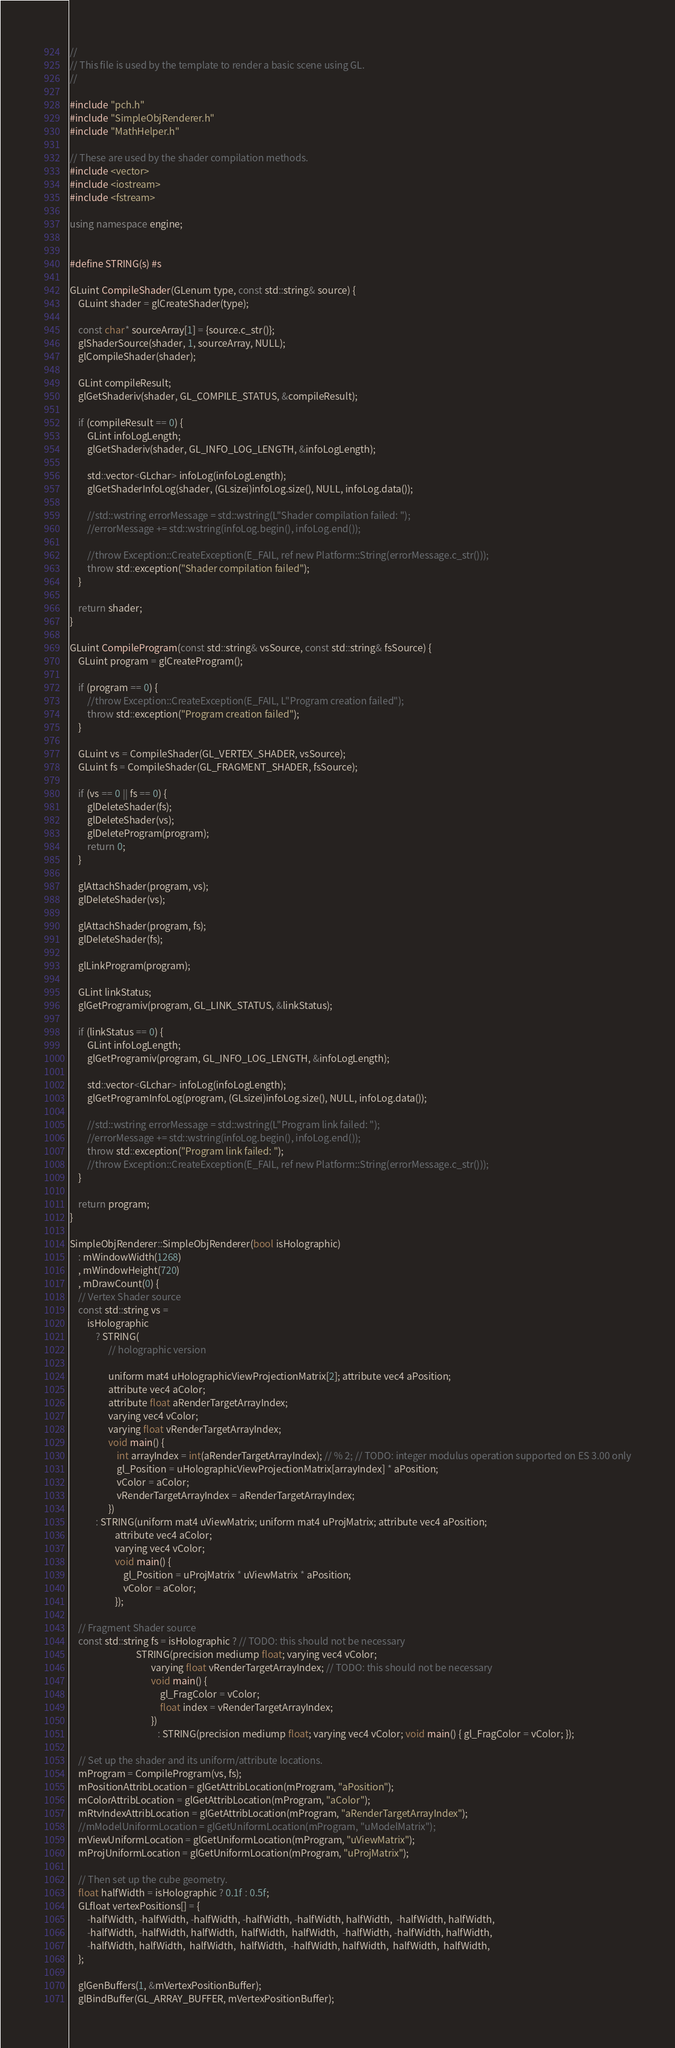<code> <loc_0><loc_0><loc_500><loc_500><_C++_>//
// This file is used by the template to render a basic scene using GL.
//

#include "pch.h"
#include "SimpleObjRenderer.h"
#include "MathHelper.h"

// These are used by the shader compilation methods.
#include <vector>
#include <iostream>
#include <fstream>

using namespace engine;


#define STRING(s) #s

GLuint CompileShader(GLenum type, const std::string& source) {
    GLuint shader = glCreateShader(type);

    const char* sourceArray[1] = {source.c_str()};
    glShaderSource(shader, 1, sourceArray, NULL);
    glCompileShader(shader);

    GLint compileResult;
    glGetShaderiv(shader, GL_COMPILE_STATUS, &compileResult);

    if (compileResult == 0) {
        GLint infoLogLength;
        glGetShaderiv(shader, GL_INFO_LOG_LENGTH, &infoLogLength);

        std::vector<GLchar> infoLog(infoLogLength);
        glGetShaderInfoLog(shader, (GLsizei)infoLog.size(), NULL, infoLog.data());

        //std::wstring errorMessage = std::wstring(L"Shader compilation failed: ");
        //errorMessage += std::wstring(infoLog.begin(), infoLog.end());

        //throw Exception::CreateException(E_FAIL, ref new Platform::String(errorMessage.c_str()));
        throw std::exception("Shader compilation failed");
    }

    return shader;
}

GLuint CompileProgram(const std::string& vsSource, const std::string& fsSource) {
    GLuint program = glCreateProgram();

    if (program == 0) {
        //throw Exception::CreateException(E_FAIL, L"Program creation failed");
        throw std::exception("Program creation failed");
    }

    GLuint vs = CompileShader(GL_VERTEX_SHADER, vsSource);
    GLuint fs = CompileShader(GL_FRAGMENT_SHADER, fsSource);

    if (vs == 0 || fs == 0) {
        glDeleteShader(fs);
        glDeleteShader(vs);
        glDeleteProgram(program);
        return 0;
    }

    glAttachShader(program, vs);
    glDeleteShader(vs);

    glAttachShader(program, fs);
    glDeleteShader(fs);

    glLinkProgram(program);

    GLint linkStatus;
    glGetProgramiv(program, GL_LINK_STATUS, &linkStatus);

    if (linkStatus == 0) {
        GLint infoLogLength;
        glGetProgramiv(program, GL_INFO_LOG_LENGTH, &infoLogLength);

        std::vector<GLchar> infoLog(infoLogLength);
        glGetProgramInfoLog(program, (GLsizei)infoLog.size(), NULL, infoLog.data());

        //std::wstring errorMessage = std::wstring(L"Program link failed: ");
        //errorMessage += std::wstring(infoLog.begin(), infoLog.end());
        throw std::exception("Program link failed: ");
        //throw Exception::CreateException(E_FAIL, ref new Platform::String(errorMessage.c_str()));
    }

    return program;
}

SimpleObjRenderer::SimpleObjRenderer(bool isHolographic)
    : mWindowWidth(1268)
    , mWindowHeight(720)
    , mDrawCount(0) {
    // Vertex Shader source
    const std::string vs =
        isHolographic
            ? STRING(
                  // holographic version

                  uniform mat4 uHolographicViewProjectionMatrix[2]; attribute vec4 aPosition;
                  attribute vec4 aColor;
                  attribute float aRenderTargetArrayIndex;
                  varying vec4 vColor;
                  varying float vRenderTargetArrayIndex;
                  void main() {
                      int arrayIndex = int(aRenderTargetArrayIndex); // % 2; // TODO: integer modulus operation supported on ES 3.00 only
                      gl_Position = uHolographicViewProjectionMatrix[arrayIndex] * aPosition;
                      vColor = aColor;
                      vRenderTargetArrayIndex = aRenderTargetArrayIndex;
                  })
            : STRING(uniform mat4 uViewMatrix; uniform mat4 uProjMatrix; attribute vec4 aPosition;
                     attribute vec4 aColor;
                     varying vec4 vColor;
                     void main() {
                         gl_Position = uProjMatrix * uViewMatrix * aPosition;
                         vColor = aColor;
                     });

    // Fragment Shader source
    const std::string fs = isHolographic ? // TODO: this should not be necessary
                               STRING(precision mediump float; varying vec4 vColor;
                                      varying float vRenderTargetArrayIndex; // TODO: this should not be necessary
                                      void main() {
                                          gl_FragColor = vColor;
                                          float index = vRenderTargetArrayIndex;
                                      })
                                         : STRING(precision mediump float; varying vec4 vColor; void main() { gl_FragColor = vColor; });

    // Set up the shader and its uniform/attribute locations.
    mProgram = CompileProgram(vs, fs);
    mPositionAttribLocation = glGetAttribLocation(mProgram, "aPosition");
    mColorAttribLocation = glGetAttribLocation(mProgram, "aColor");
    mRtvIndexAttribLocation = glGetAttribLocation(mProgram, "aRenderTargetArrayIndex");
    //mModelUniformLocation = glGetUniformLocation(mProgram, "uModelMatrix");
    mViewUniformLocation = glGetUniformLocation(mProgram, "uViewMatrix");
    mProjUniformLocation = glGetUniformLocation(mProgram, "uProjMatrix");

    // Then set up the cube geometry.
    float halfWidth = isHolographic ? 0.1f : 0.5f;
    GLfloat vertexPositions[] = {
        -halfWidth, -halfWidth, -halfWidth, -halfWidth, -halfWidth, halfWidth,  -halfWidth, halfWidth,
        -halfWidth, -halfWidth, halfWidth,  halfWidth,  halfWidth,  -halfWidth, -halfWidth, halfWidth,
        -halfWidth, halfWidth,  halfWidth,  halfWidth,  -halfWidth, halfWidth,  halfWidth,  halfWidth,
    };

    glGenBuffers(1, &mVertexPositionBuffer);
    glBindBuffer(GL_ARRAY_BUFFER, mVertexPositionBuffer);</code> 